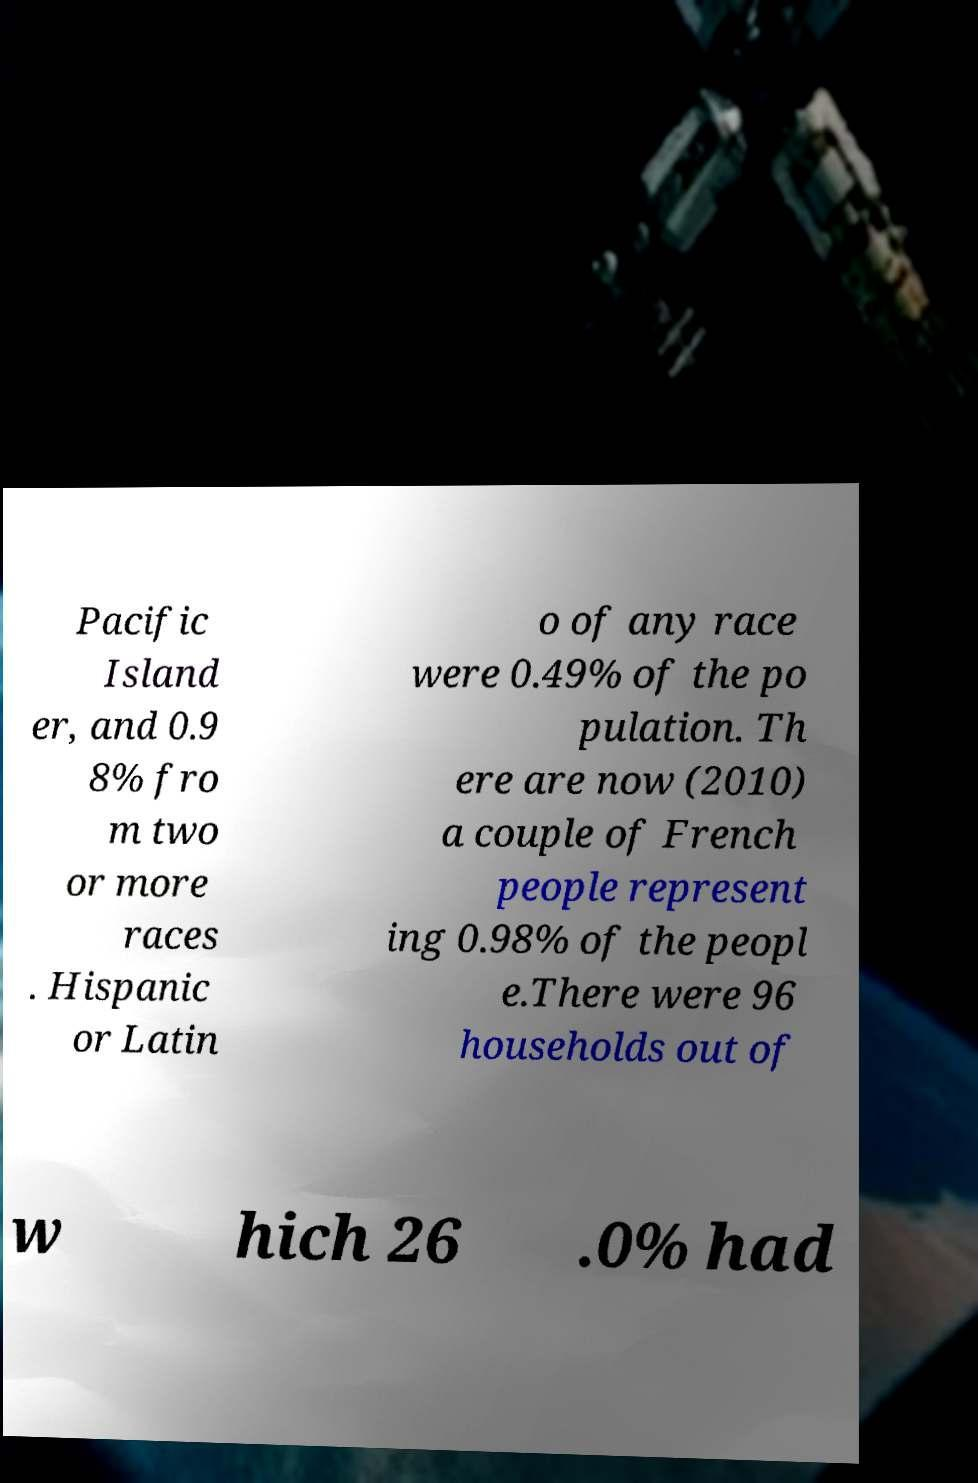Please identify and transcribe the text found in this image. Pacific Island er, and 0.9 8% fro m two or more races . Hispanic or Latin o of any race were 0.49% of the po pulation. Th ere are now (2010) a couple of French people represent ing 0.98% of the peopl e.There were 96 households out of w hich 26 .0% had 